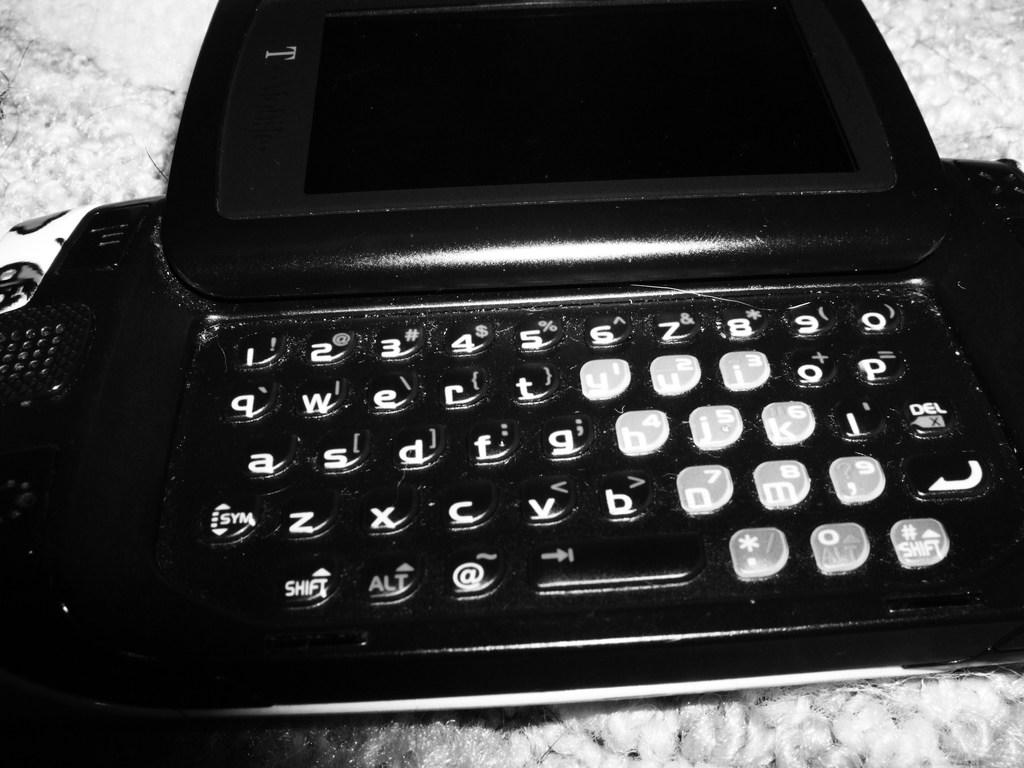<image>
Relay a brief, clear account of the picture shown. A keyboard has a white letter d in gloss. 